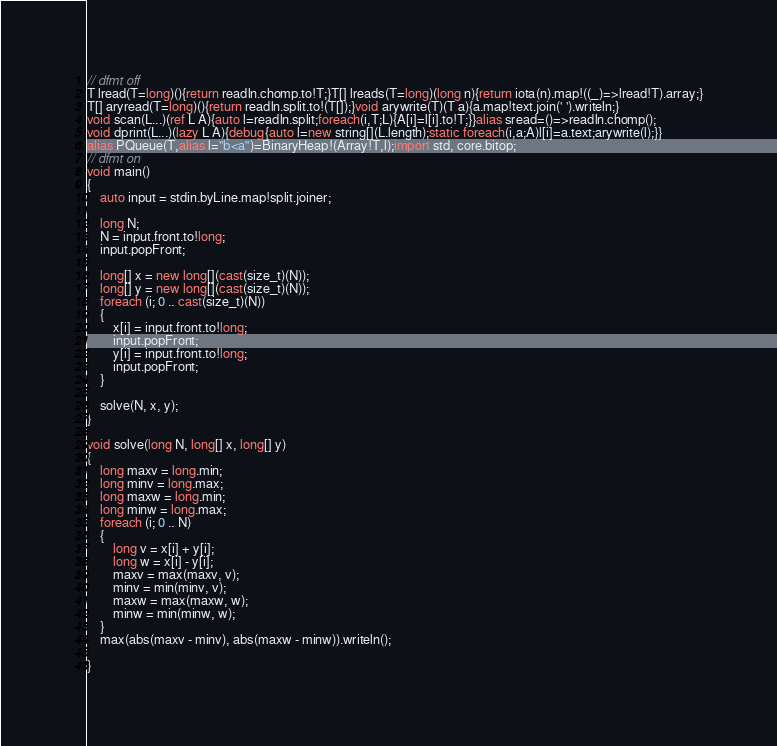Convert code to text. <code><loc_0><loc_0><loc_500><loc_500><_D_>// dfmt off
T lread(T=long)(){return readln.chomp.to!T;}T[] lreads(T=long)(long n){return iota(n).map!((_)=>lread!T).array;}
T[] aryread(T=long)(){return readln.split.to!(T[]);}void arywrite(T)(T a){a.map!text.join(' ').writeln;}
void scan(L...)(ref L A){auto l=readln.split;foreach(i,T;L){A[i]=l[i].to!T;}}alias sread=()=>readln.chomp();
void dprint(L...)(lazy L A){debug{auto l=new string[](L.length);static foreach(i,a;A)l[i]=a.text;arywrite(l);}}
alias PQueue(T,alias l="b<a")=BinaryHeap!(Array!T,l);import std, core.bitop;
// dfmt on
void main()
{
    auto input = stdin.byLine.map!split.joiner;

    long N;
    N = input.front.to!long;
    input.popFront;

    long[] x = new long[](cast(size_t)(N));
    long[] y = new long[](cast(size_t)(N));
    foreach (i; 0 .. cast(size_t)(N))
    {
        x[i] = input.front.to!long;
        input.popFront;
        y[i] = input.front.to!long;
        input.popFront;
    }

    solve(N, x, y);
}

void solve(long N, long[] x, long[] y)
{
    long maxv = long.min;
    long minv = long.max;
    long maxw = long.min;
    long minw = long.max;
    foreach (i; 0 .. N)
    {
        long v = x[i] + y[i];
        long w = x[i] - y[i];
        maxv = max(maxv, v);
        minv = min(minv, v);
        maxw = max(maxw, w);
        minw = min(minw, w);
    }
    max(abs(maxv - minv), abs(maxw - minw)).writeln();

}
</code> 